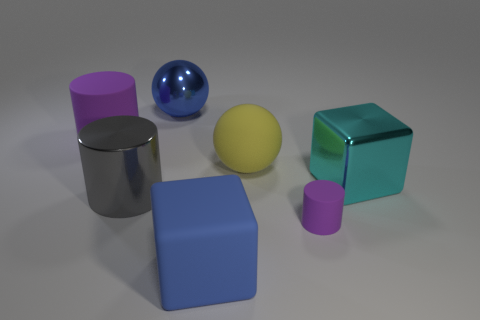Add 3 yellow blocks. How many objects exist? 10 Subtract all cubes. How many objects are left? 5 Add 4 purple matte cylinders. How many purple matte cylinders are left? 6 Add 6 blue cubes. How many blue cubes exist? 7 Subtract 0 brown blocks. How many objects are left? 7 Subtract all large matte balls. Subtract all big gray things. How many objects are left? 5 